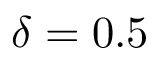<formula> <loc_0><loc_0><loc_500><loc_500>\delta = 0 . 5</formula> 